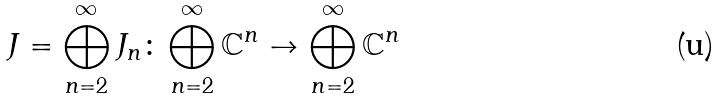Convert formula to latex. <formula><loc_0><loc_0><loc_500><loc_500>J = \bigoplus _ { n = 2 } ^ { \infty } J _ { n } \colon \bigoplus _ { n = 2 } ^ { \infty } \mathbb { C } ^ { n } \to \bigoplus _ { n = 2 } ^ { \infty } \mathbb { C } ^ { n }</formula> 